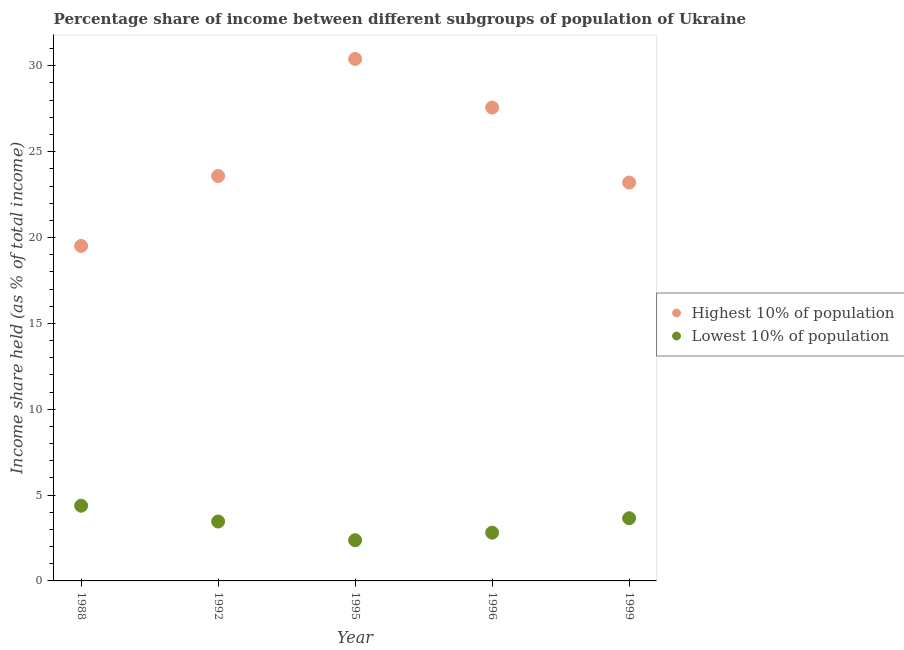What is the income share held by highest 10% of the population in 1999?
Offer a terse response. 23.2. Across all years, what is the maximum income share held by highest 10% of the population?
Your response must be concise. 30.4. Across all years, what is the minimum income share held by lowest 10% of the population?
Your response must be concise. 2.37. In which year was the income share held by highest 10% of the population minimum?
Ensure brevity in your answer.  1988. What is the total income share held by highest 10% of the population in the graph?
Your response must be concise. 124.26. What is the difference between the income share held by lowest 10% of the population in 1992 and that in 1995?
Make the answer very short. 1.09. What is the difference between the income share held by highest 10% of the population in 1999 and the income share held by lowest 10% of the population in 1995?
Offer a terse response. 20.83. What is the average income share held by lowest 10% of the population per year?
Give a very brief answer. 3.33. In the year 1988, what is the difference between the income share held by lowest 10% of the population and income share held by highest 10% of the population?
Your answer should be very brief. -15.13. What is the ratio of the income share held by highest 10% of the population in 1988 to that in 1999?
Offer a terse response. 0.84. Is the income share held by lowest 10% of the population in 1992 less than that in 1995?
Keep it short and to the point. No. What is the difference between the highest and the second highest income share held by lowest 10% of the population?
Give a very brief answer. 0.73. What is the difference between the highest and the lowest income share held by highest 10% of the population?
Provide a succinct answer. 10.89. In how many years, is the income share held by highest 10% of the population greater than the average income share held by highest 10% of the population taken over all years?
Provide a succinct answer. 2. Does the income share held by highest 10% of the population monotonically increase over the years?
Ensure brevity in your answer.  No. Is the income share held by lowest 10% of the population strictly less than the income share held by highest 10% of the population over the years?
Your response must be concise. Yes. What is the difference between two consecutive major ticks on the Y-axis?
Keep it short and to the point. 5. Does the graph contain grids?
Ensure brevity in your answer.  No. Where does the legend appear in the graph?
Your answer should be compact. Center right. What is the title of the graph?
Provide a short and direct response. Percentage share of income between different subgroups of population of Ukraine. What is the label or title of the X-axis?
Your response must be concise. Year. What is the label or title of the Y-axis?
Provide a short and direct response. Income share held (as % of total income). What is the Income share held (as % of total income) of Highest 10% of population in 1988?
Offer a terse response. 19.51. What is the Income share held (as % of total income) in Lowest 10% of population in 1988?
Make the answer very short. 4.38. What is the Income share held (as % of total income) of Highest 10% of population in 1992?
Provide a short and direct response. 23.58. What is the Income share held (as % of total income) in Lowest 10% of population in 1992?
Your answer should be very brief. 3.46. What is the Income share held (as % of total income) of Highest 10% of population in 1995?
Offer a very short reply. 30.4. What is the Income share held (as % of total income) in Lowest 10% of population in 1995?
Offer a terse response. 2.37. What is the Income share held (as % of total income) in Highest 10% of population in 1996?
Ensure brevity in your answer.  27.57. What is the Income share held (as % of total income) of Lowest 10% of population in 1996?
Make the answer very short. 2.81. What is the Income share held (as % of total income) of Highest 10% of population in 1999?
Keep it short and to the point. 23.2. What is the Income share held (as % of total income) of Lowest 10% of population in 1999?
Provide a succinct answer. 3.65. Across all years, what is the maximum Income share held (as % of total income) in Highest 10% of population?
Make the answer very short. 30.4. Across all years, what is the maximum Income share held (as % of total income) in Lowest 10% of population?
Offer a very short reply. 4.38. Across all years, what is the minimum Income share held (as % of total income) in Highest 10% of population?
Offer a very short reply. 19.51. Across all years, what is the minimum Income share held (as % of total income) in Lowest 10% of population?
Offer a terse response. 2.37. What is the total Income share held (as % of total income) of Highest 10% of population in the graph?
Your response must be concise. 124.26. What is the total Income share held (as % of total income) in Lowest 10% of population in the graph?
Your answer should be very brief. 16.67. What is the difference between the Income share held (as % of total income) of Highest 10% of population in 1988 and that in 1992?
Offer a very short reply. -4.07. What is the difference between the Income share held (as % of total income) of Highest 10% of population in 1988 and that in 1995?
Ensure brevity in your answer.  -10.89. What is the difference between the Income share held (as % of total income) in Lowest 10% of population in 1988 and that in 1995?
Provide a succinct answer. 2.01. What is the difference between the Income share held (as % of total income) of Highest 10% of population in 1988 and that in 1996?
Your answer should be compact. -8.06. What is the difference between the Income share held (as % of total income) of Lowest 10% of population in 1988 and that in 1996?
Your answer should be very brief. 1.57. What is the difference between the Income share held (as % of total income) in Highest 10% of population in 1988 and that in 1999?
Offer a terse response. -3.69. What is the difference between the Income share held (as % of total income) of Lowest 10% of population in 1988 and that in 1999?
Offer a terse response. 0.73. What is the difference between the Income share held (as % of total income) of Highest 10% of population in 1992 and that in 1995?
Offer a terse response. -6.82. What is the difference between the Income share held (as % of total income) of Lowest 10% of population in 1992 and that in 1995?
Your answer should be compact. 1.09. What is the difference between the Income share held (as % of total income) of Highest 10% of population in 1992 and that in 1996?
Keep it short and to the point. -3.99. What is the difference between the Income share held (as % of total income) of Lowest 10% of population in 1992 and that in 1996?
Your response must be concise. 0.65. What is the difference between the Income share held (as % of total income) of Highest 10% of population in 1992 and that in 1999?
Give a very brief answer. 0.38. What is the difference between the Income share held (as % of total income) of Lowest 10% of population in 1992 and that in 1999?
Offer a very short reply. -0.19. What is the difference between the Income share held (as % of total income) of Highest 10% of population in 1995 and that in 1996?
Your answer should be very brief. 2.83. What is the difference between the Income share held (as % of total income) of Lowest 10% of population in 1995 and that in 1996?
Your answer should be compact. -0.44. What is the difference between the Income share held (as % of total income) of Highest 10% of population in 1995 and that in 1999?
Offer a terse response. 7.2. What is the difference between the Income share held (as % of total income) of Lowest 10% of population in 1995 and that in 1999?
Provide a short and direct response. -1.28. What is the difference between the Income share held (as % of total income) in Highest 10% of population in 1996 and that in 1999?
Your answer should be very brief. 4.37. What is the difference between the Income share held (as % of total income) of Lowest 10% of population in 1996 and that in 1999?
Your answer should be very brief. -0.84. What is the difference between the Income share held (as % of total income) of Highest 10% of population in 1988 and the Income share held (as % of total income) of Lowest 10% of population in 1992?
Your answer should be very brief. 16.05. What is the difference between the Income share held (as % of total income) in Highest 10% of population in 1988 and the Income share held (as % of total income) in Lowest 10% of population in 1995?
Your answer should be compact. 17.14. What is the difference between the Income share held (as % of total income) of Highest 10% of population in 1988 and the Income share held (as % of total income) of Lowest 10% of population in 1999?
Ensure brevity in your answer.  15.86. What is the difference between the Income share held (as % of total income) of Highest 10% of population in 1992 and the Income share held (as % of total income) of Lowest 10% of population in 1995?
Provide a succinct answer. 21.21. What is the difference between the Income share held (as % of total income) in Highest 10% of population in 1992 and the Income share held (as % of total income) in Lowest 10% of population in 1996?
Provide a short and direct response. 20.77. What is the difference between the Income share held (as % of total income) of Highest 10% of population in 1992 and the Income share held (as % of total income) of Lowest 10% of population in 1999?
Keep it short and to the point. 19.93. What is the difference between the Income share held (as % of total income) in Highest 10% of population in 1995 and the Income share held (as % of total income) in Lowest 10% of population in 1996?
Ensure brevity in your answer.  27.59. What is the difference between the Income share held (as % of total income) of Highest 10% of population in 1995 and the Income share held (as % of total income) of Lowest 10% of population in 1999?
Your answer should be compact. 26.75. What is the difference between the Income share held (as % of total income) in Highest 10% of population in 1996 and the Income share held (as % of total income) in Lowest 10% of population in 1999?
Ensure brevity in your answer.  23.92. What is the average Income share held (as % of total income) in Highest 10% of population per year?
Provide a short and direct response. 24.85. What is the average Income share held (as % of total income) of Lowest 10% of population per year?
Keep it short and to the point. 3.33. In the year 1988, what is the difference between the Income share held (as % of total income) of Highest 10% of population and Income share held (as % of total income) of Lowest 10% of population?
Make the answer very short. 15.13. In the year 1992, what is the difference between the Income share held (as % of total income) of Highest 10% of population and Income share held (as % of total income) of Lowest 10% of population?
Give a very brief answer. 20.12. In the year 1995, what is the difference between the Income share held (as % of total income) in Highest 10% of population and Income share held (as % of total income) in Lowest 10% of population?
Offer a very short reply. 28.03. In the year 1996, what is the difference between the Income share held (as % of total income) in Highest 10% of population and Income share held (as % of total income) in Lowest 10% of population?
Ensure brevity in your answer.  24.76. In the year 1999, what is the difference between the Income share held (as % of total income) of Highest 10% of population and Income share held (as % of total income) of Lowest 10% of population?
Ensure brevity in your answer.  19.55. What is the ratio of the Income share held (as % of total income) of Highest 10% of population in 1988 to that in 1992?
Your answer should be very brief. 0.83. What is the ratio of the Income share held (as % of total income) of Lowest 10% of population in 1988 to that in 1992?
Give a very brief answer. 1.27. What is the ratio of the Income share held (as % of total income) in Highest 10% of population in 1988 to that in 1995?
Your answer should be very brief. 0.64. What is the ratio of the Income share held (as % of total income) of Lowest 10% of population in 1988 to that in 1995?
Make the answer very short. 1.85. What is the ratio of the Income share held (as % of total income) of Highest 10% of population in 1988 to that in 1996?
Keep it short and to the point. 0.71. What is the ratio of the Income share held (as % of total income) in Lowest 10% of population in 1988 to that in 1996?
Your response must be concise. 1.56. What is the ratio of the Income share held (as % of total income) of Highest 10% of population in 1988 to that in 1999?
Ensure brevity in your answer.  0.84. What is the ratio of the Income share held (as % of total income) in Lowest 10% of population in 1988 to that in 1999?
Ensure brevity in your answer.  1.2. What is the ratio of the Income share held (as % of total income) in Highest 10% of population in 1992 to that in 1995?
Ensure brevity in your answer.  0.78. What is the ratio of the Income share held (as % of total income) in Lowest 10% of population in 1992 to that in 1995?
Your response must be concise. 1.46. What is the ratio of the Income share held (as % of total income) in Highest 10% of population in 1992 to that in 1996?
Your response must be concise. 0.86. What is the ratio of the Income share held (as % of total income) of Lowest 10% of population in 1992 to that in 1996?
Your response must be concise. 1.23. What is the ratio of the Income share held (as % of total income) of Highest 10% of population in 1992 to that in 1999?
Provide a short and direct response. 1.02. What is the ratio of the Income share held (as % of total income) of Lowest 10% of population in 1992 to that in 1999?
Keep it short and to the point. 0.95. What is the ratio of the Income share held (as % of total income) in Highest 10% of population in 1995 to that in 1996?
Make the answer very short. 1.1. What is the ratio of the Income share held (as % of total income) of Lowest 10% of population in 1995 to that in 1996?
Your answer should be compact. 0.84. What is the ratio of the Income share held (as % of total income) of Highest 10% of population in 1995 to that in 1999?
Offer a terse response. 1.31. What is the ratio of the Income share held (as % of total income) of Lowest 10% of population in 1995 to that in 1999?
Keep it short and to the point. 0.65. What is the ratio of the Income share held (as % of total income) in Highest 10% of population in 1996 to that in 1999?
Provide a short and direct response. 1.19. What is the ratio of the Income share held (as % of total income) in Lowest 10% of population in 1996 to that in 1999?
Offer a terse response. 0.77. What is the difference between the highest and the second highest Income share held (as % of total income) of Highest 10% of population?
Ensure brevity in your answer.  2.83. What is the difference between the highest and the second highest Income share held (as % of total income) in Lowest 10% of population?
Your answer should be very brief. 0.73. What is the difference between the highest and the lowest Income share held (as % of total income) of Highest 10% of population?
Your response must be concise. 10.89. What is the difference between the highest and the lowest Income share held (as % of total income) of Lowest 10% of population?
Provide a succinct answer. 2.01. 